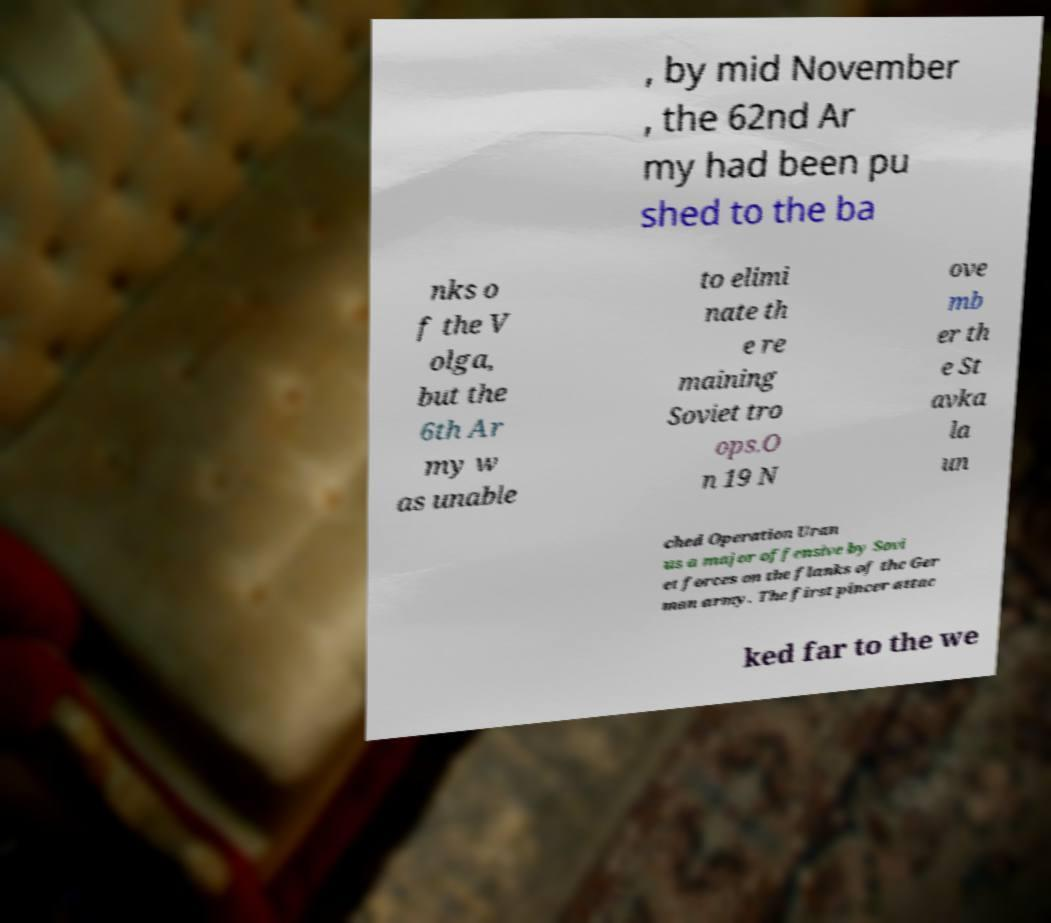For documentation purposes, I need the text within this image transcribed. Could you provide that? , by mid November , the 62nd Ar my had been pu shed to the ba nks o f the V olga, but the 6th Ar my w as unable to elimi nate th e re maining Soviet tro ops.O n 19 N ove mb er th e St avka la un ched Operation Uran us a major offensive by Sovi et forces on the flanks of the Ger man army. The first pincer attac ked far to the we 